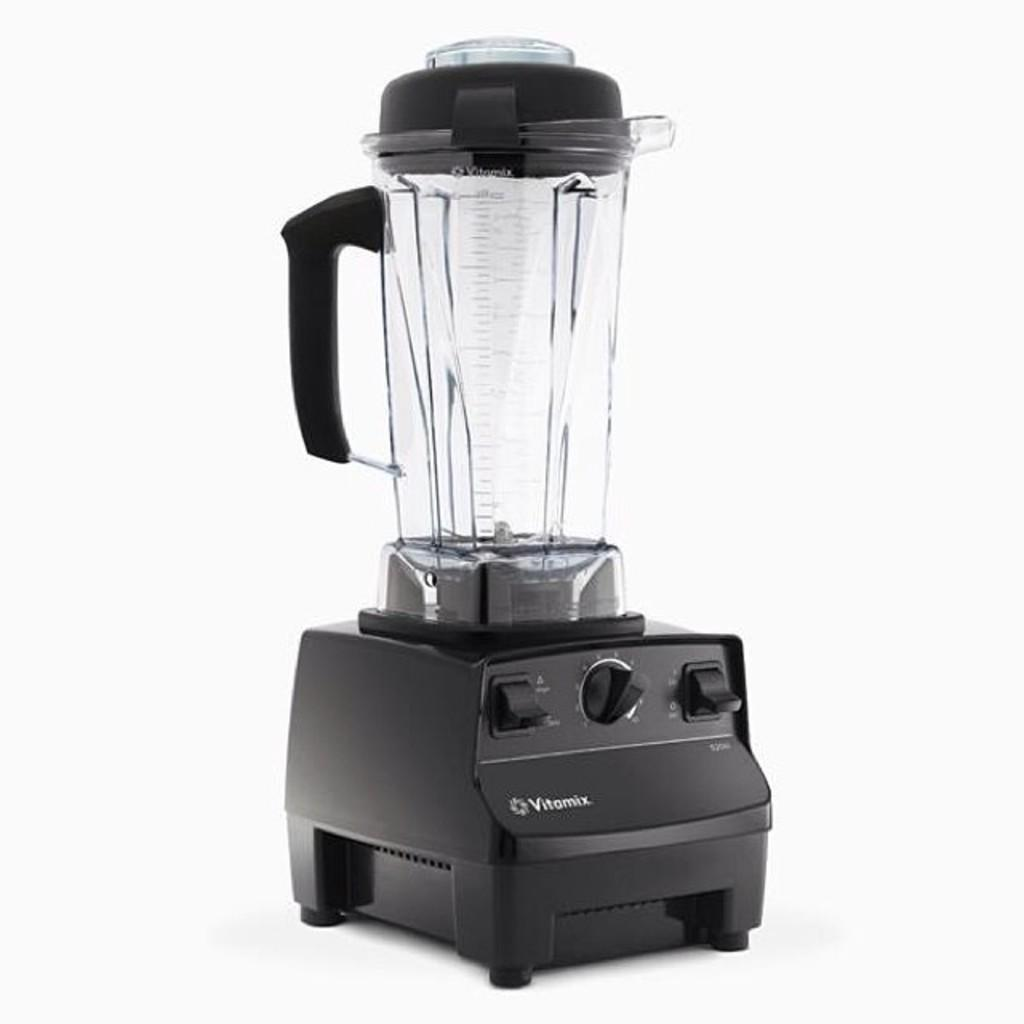<image>
Offer a succinct explanation of the picture presented. A black Vitamix blender with one knob and 2 switches. 